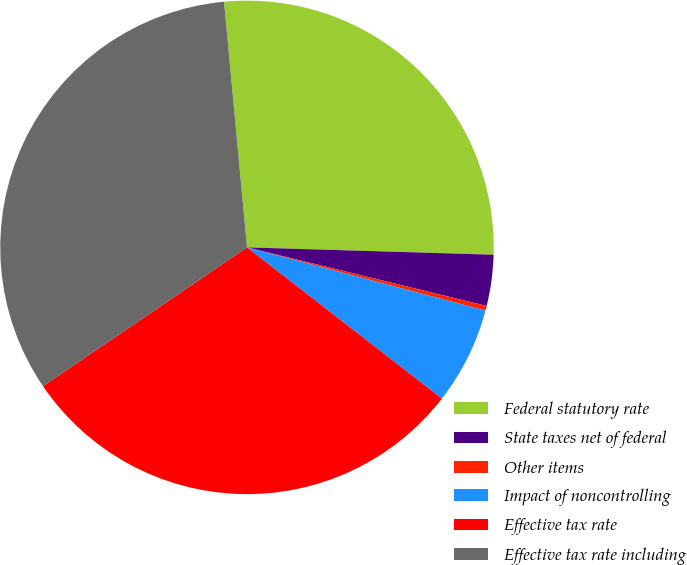Convert chart. <chart><loc_0><loc_0><loc_500><loc_500><pie_chart><fcel>Federal statutory rate<fcel>State taxes net of federal<fcel>Other items<fcel>Impact of noncontrolling<fcel>Effective tax rate<fcel>Effective tax rate including<nl><fcel>26.96%<fcel>3.34%<fcel>0.31%<fcel>6.38%<fcel>29.99%<fcel>33.03%<nl></chart> 